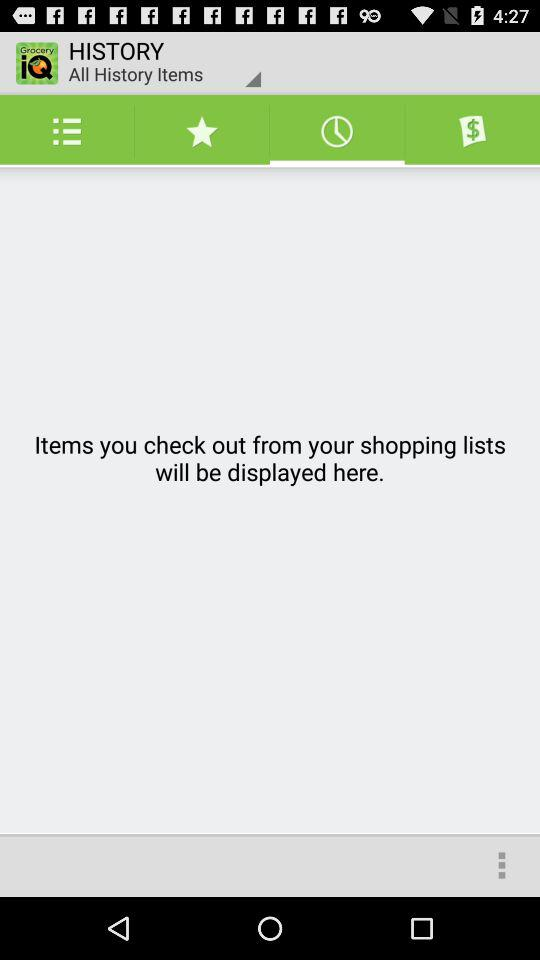What is the name of the application? The name of the application is "Grocery iQ". 